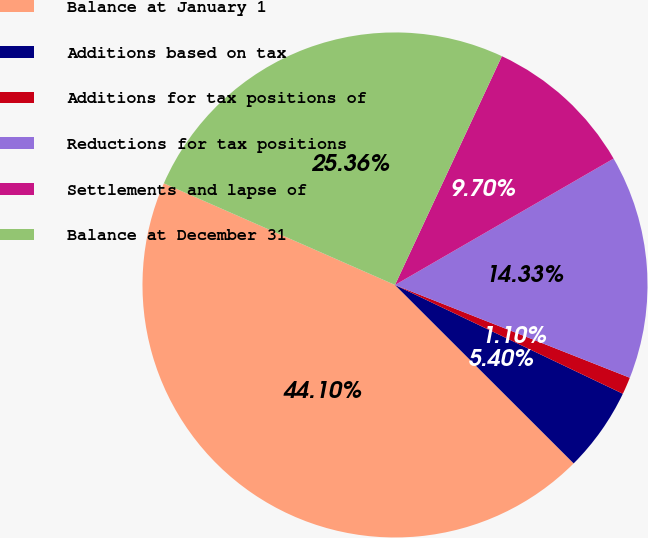<chart> <loc_0><loc_0><loc_500><loc_500><pie_chart><fcel>Balance at January 1<fcel>Additions based on tax<fcel>Additions for tax positions of<fcel>Reductions for tax positions<fcel>Settlements and lapse of<fcel>Balance at December 31<nl><fcel>44.1%<fcel>5.4%<fcel>1.1%<fcel>14.33%<fcel>9.7%<fcel>25.36%<nl></chart> 